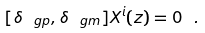<formula> <loc_0><loc_0><loc_500><loc_500>[ \delta _ { \ g p } , \delta _ { \ g m } ] X ^ { i } ( z ) = 0 \ .</formula> 